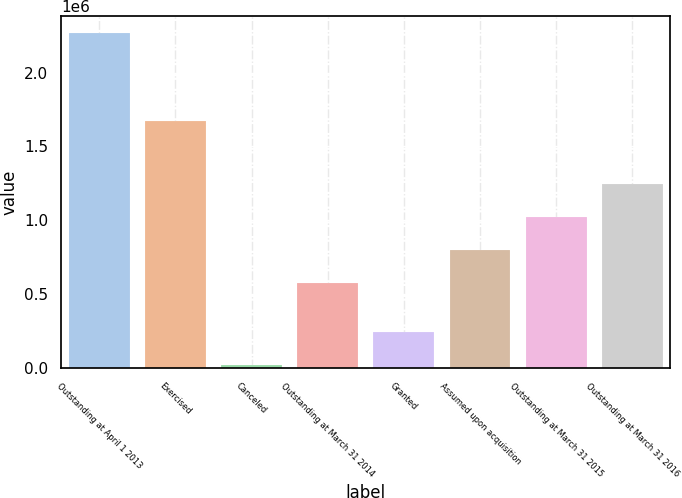Convert chart to OTSL. <chart><loc_0><loc_0><loc_500><loc_500><bar_chart><fcel>Outstanding at April 1 2013<fcel>Exercised<fcel>Canceled<fcel>Outstanding at March 31 2014<fcel>Granted<fcel>Assumed upon acquisition<fcel>Outstanding at March 31 2015<fcel>Outstanding at March 31 2016<nl><fcel>2.2698e+06<fcel>1.67566e+06<fcel>20529<fcel>573611<fcel>245456<fcel>798538<fcel>1.02347e+06<fcel>1.24839e+06<nl></chart> 